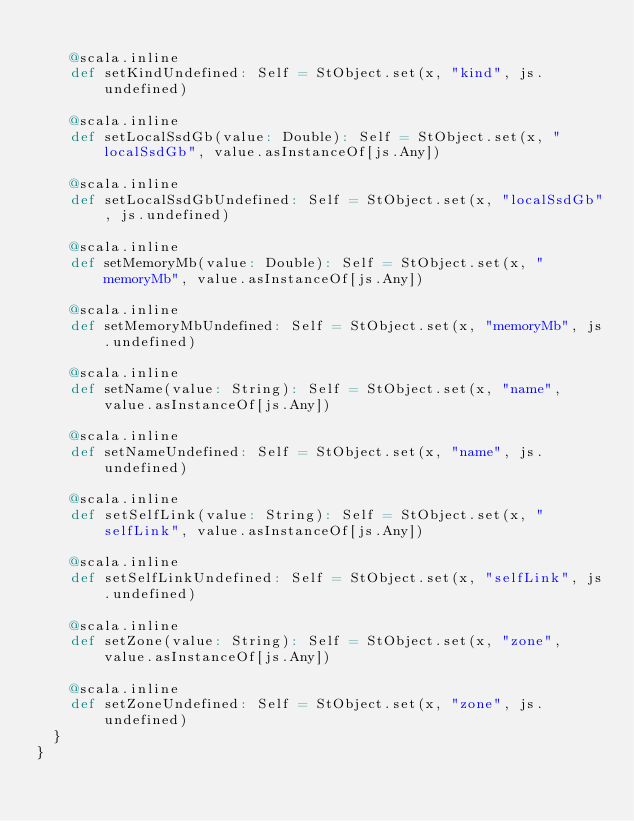Convert code to text. <code><loc_0><loc_0><loc_500><loc_500><_Scala_>    
    @scala.inline
    def setKindUndefined: Self = StObject.set(x, "kind", js.undefined)
    
    @scala.inline
    def setLocalSsdGb(value: Double): Self = StObject.set(x, "localSsdGb", value.asInstanceOf[js.Any])
    
    @scala.inline
    def setLocalSsdGbUndefined: Self = StObject.set(x, "localSsdGb", js.undefined)
    
    @scala.inline
    def setMemoryMb(value: Double): Self = StObject.set(x, "memoryMb", value.asInstanceOf[js.Any])
    
    @scala.inline
    def setMemoryMbUndefined: Self = StObject.set(x, "memoryMb", js.undefined)
    
    @scala.inline
    def setName(value: String): Self = StObject.set(x, "name", value.asInstanceOf[js.Any])
    
    @scala.inline
    def setNameUndefined: Self = StObject.set(x, "name", js.undefined)
    
    @scala.inline
    def setSelfLink(value: String): Self = StObject.set(x, "selfLink", value.asInstanceOf[js.Any])
    
    @scala.inline
    def setSelfLinkUndefined: Self = StObject.set(x, "selfLink", js.undefined)
    
    @scala.inline
    def setZone(value: String): Self = StObject.set(x, "zone", value.asInstanceOf[js.Any])
    
    @scala.inline
    def setZoneUndefined: Self = StObject.set(x, "zone", js.undefined)
  }
}
</code> 